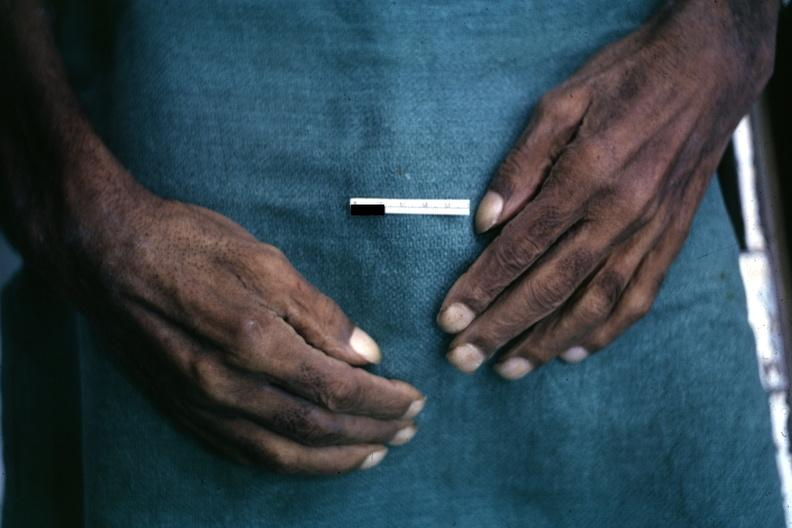what does this image show?
Answer the question using a single word or phrase. Obvious lesion 